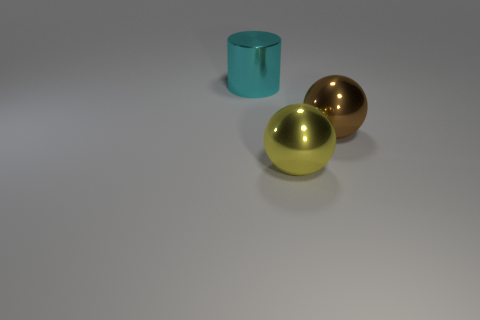Can you describe the texture of the objects? Certainly! The two spheres appear to have a smooth texture, indicated by their shiny surfaces and clear reflections. The cylindrical object, however, has a matte finish, which suggests a more diffuse and non-reflective texture. 